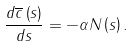Convert formula to latex. <formula><loc_0><loc_0><loc_500><loc_500>\frac { d \overline { c } \left ( s \right ) } { d s } = - \alpha N \left ( s \right ) .</formula> 